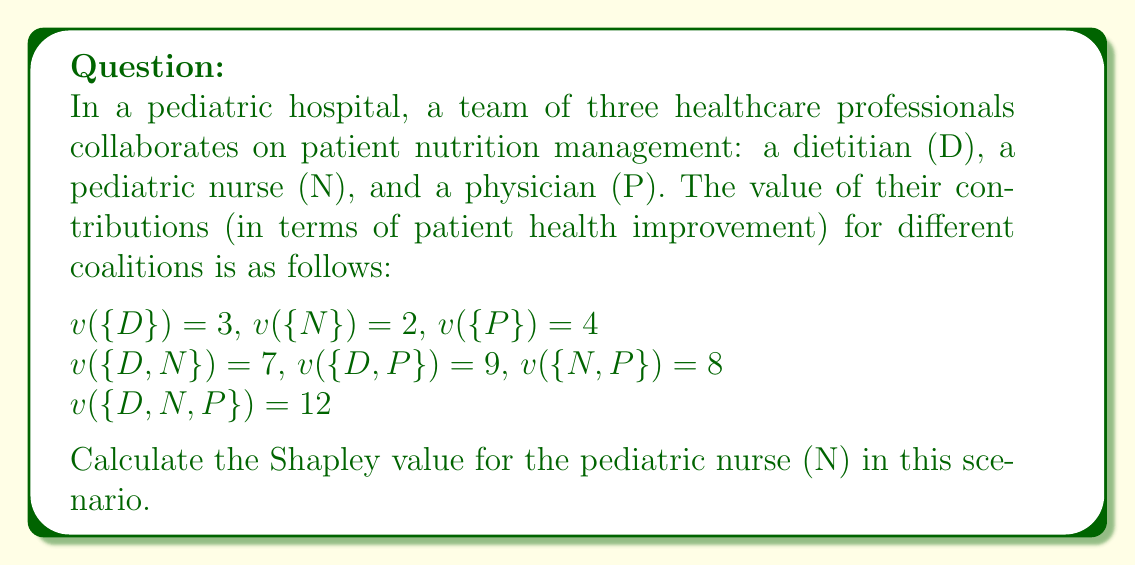Solve this math problem. To calculate the Shapley value for the pediatric nurse (N), we need to determine their marginal contribution in all possible coalition formations and then take the average. The formula for the Shapley value is:

$$ \phi_i(v) = \sum_{S \subseteq N \setminus \{i\}} \frac{|S|!(n-|S|-1)!}{n!}[v(S \cup \{i\}) - v(S)] $$

Where:
$i$ is the player (in this case, N)
$N$ is the set of all players
$S$ is a subset of $N$ not containing $i$
$n$ is the total number of players
$v$ is the characteristic function

For the pediatric nurse (N), we need to consider the following scenarios:

1. N joins empty set: $v(\{N\}) - v(\{\}) = 2 - 0 = 2$
2. N joins D: $v(\{D,N\}) - v(\{D\}) = 7 - 3 = 4$
3. N joins P: $v(\{N,P\}) - v(\{P\}) = 8 - 4 = 4$
4. N joins D and P: $v(\{D,N,P\}) - v(\{D,P\}) = 12 - 9 = 3$

Now, we calculate the Shapley value:

$$ \phi_N(v) = \frac{2!(3-2-1)!}{3!}(2) + \frac{1!(3-1-1)!}{3!}(4) + \frac{1!(3-1-1)!}{3!}(4) + \frac{2!(3-2-1)!}{3!}(3) $$

$$ = \frac{2}{6}(2) + \frac{1}{6}(4) + \frac{1}{6}(4) + \frac{2}{6}(3) $$

$$ = \frac{4}{6} + \frac{4}{6} + \frac{4}{6} + \frac{6}{6} $$

$$ = 3 $$
Answer: The Shapley value for the pediatric nurse (N) is 3. 